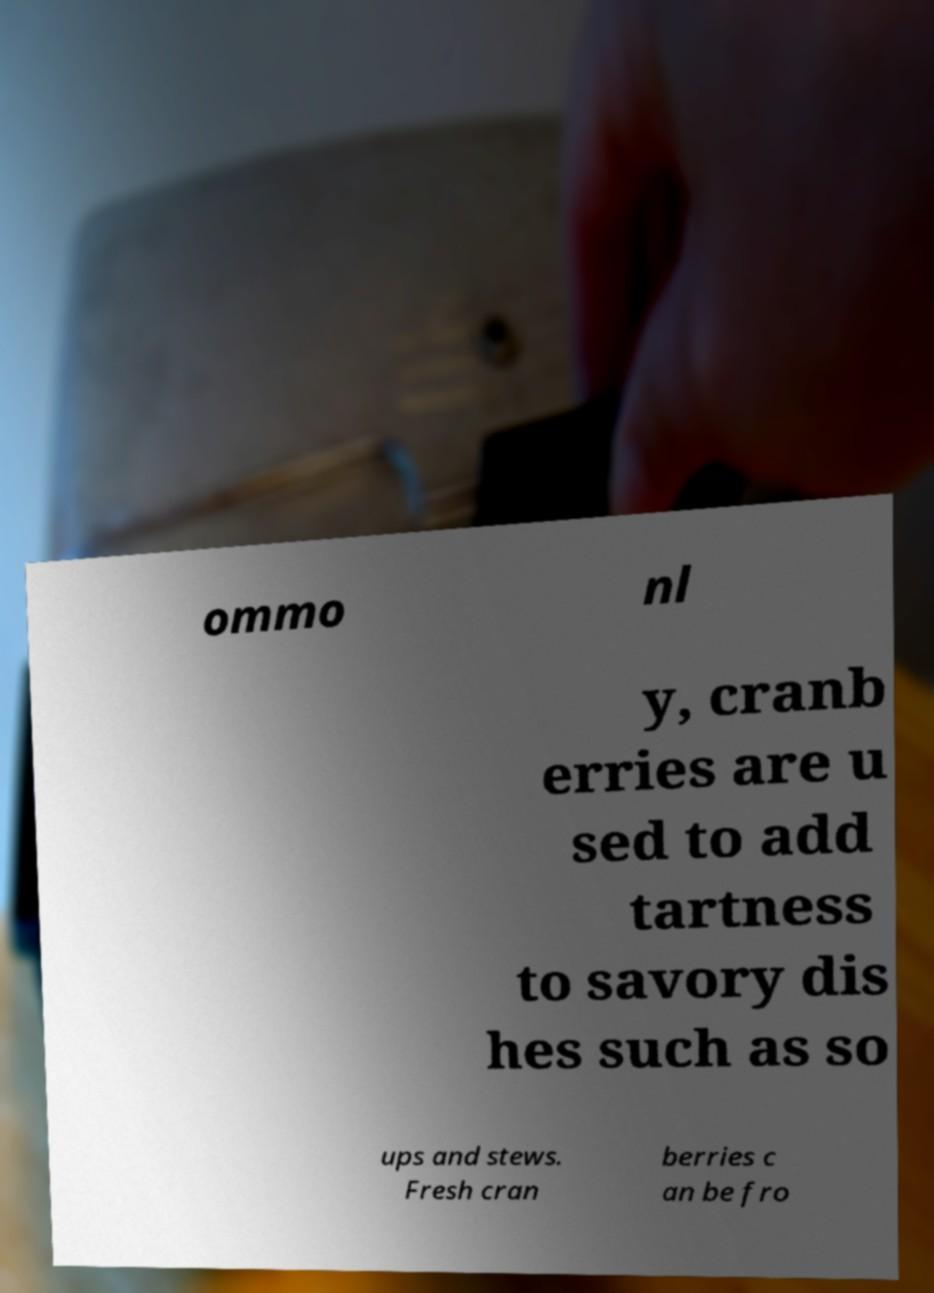Could you assist in decoding the text presented in this image and type it out clearly? ommo nl y, cranb erries are u sed to add tartness to savory dis hes such as so ups and stews. Fresh cran berries c an be fro 